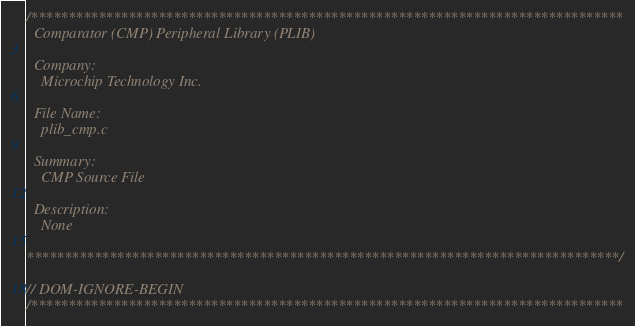Convert code to text. <code><loc_0><loc_0><loc_500><loc_500><_C_>/*******************************************************************************
  Comparator (CMP) Peripheral Library (PLIB)

  Company:
    Microchip Technology Inc.

  File Name:
    plib_cmp.c

  Summary:
    CMP Source File

  Description:
    None

*******************************************************************************/

// DOM-IGNORE-BEGIN
/*******************************************************************************</code> 